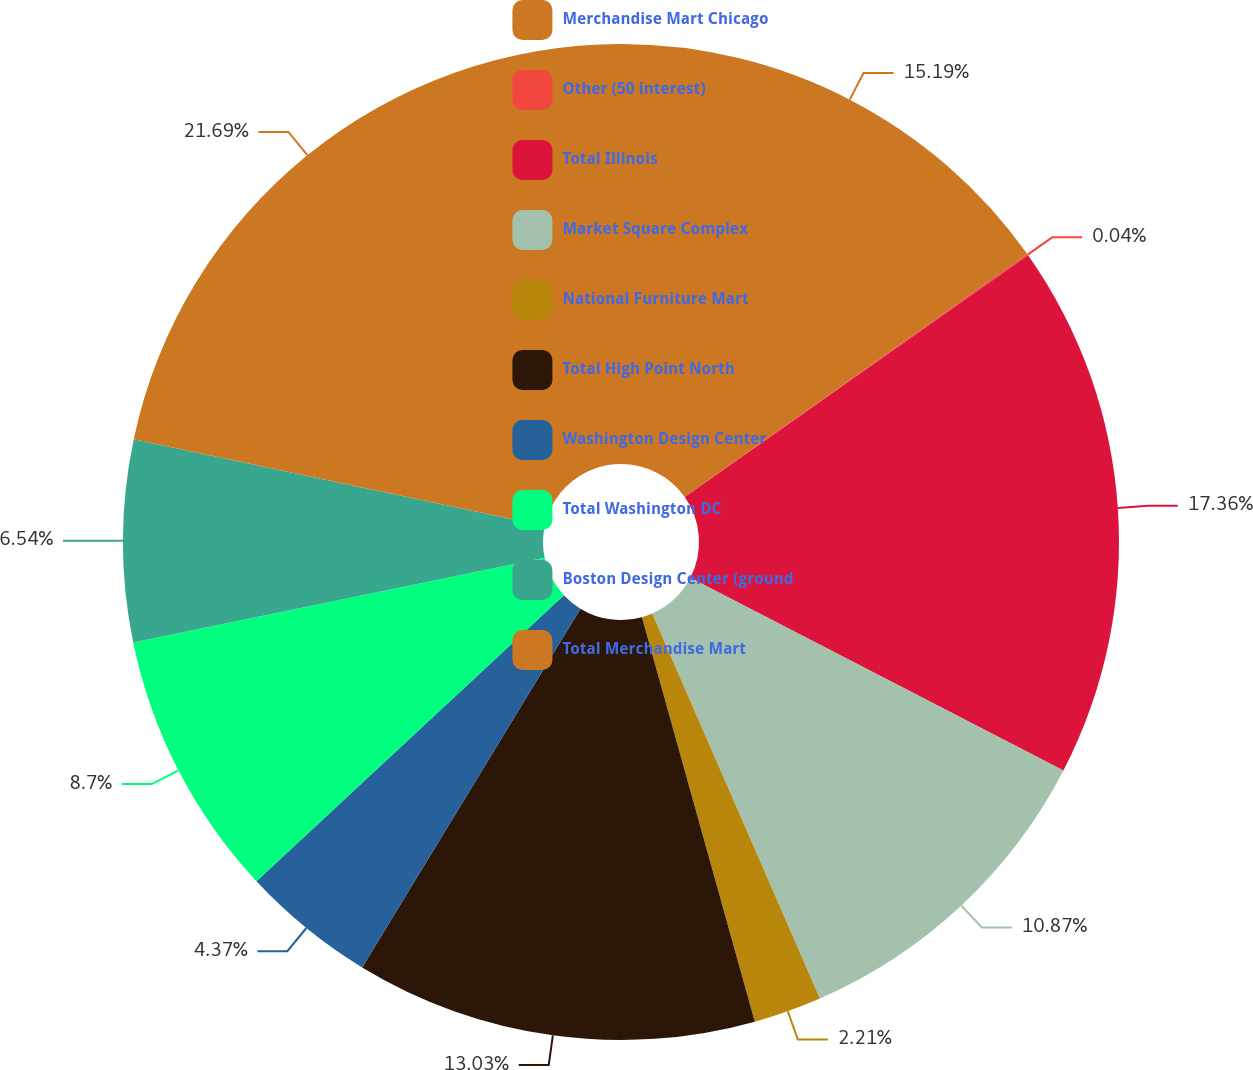Convert chart. <chart><loc_0><loc_0><loc_500><loc_500><pie_chart><fcel>Merchandise Mart Chicago<fcel>Other (50 interest)<fcel>Total Illinois<fcel>Market Square Complex<fcel>National Furniture Mart<fcel>Total High Point North<fcel>Washington Design Center<fcel>Total Washington DC<fcel>Boston Design Center (ground<fcel>Total Merchandise Mart<nl><fcel>15.19%<fcel>0.04%<fcel>17.36%<fcel>10.87%<fcel>2.21%<fcel>13.03%<fcel>4.37%<fcel>8.7%<fcel>6.54%<fcel>21.69%<nl></chart> 